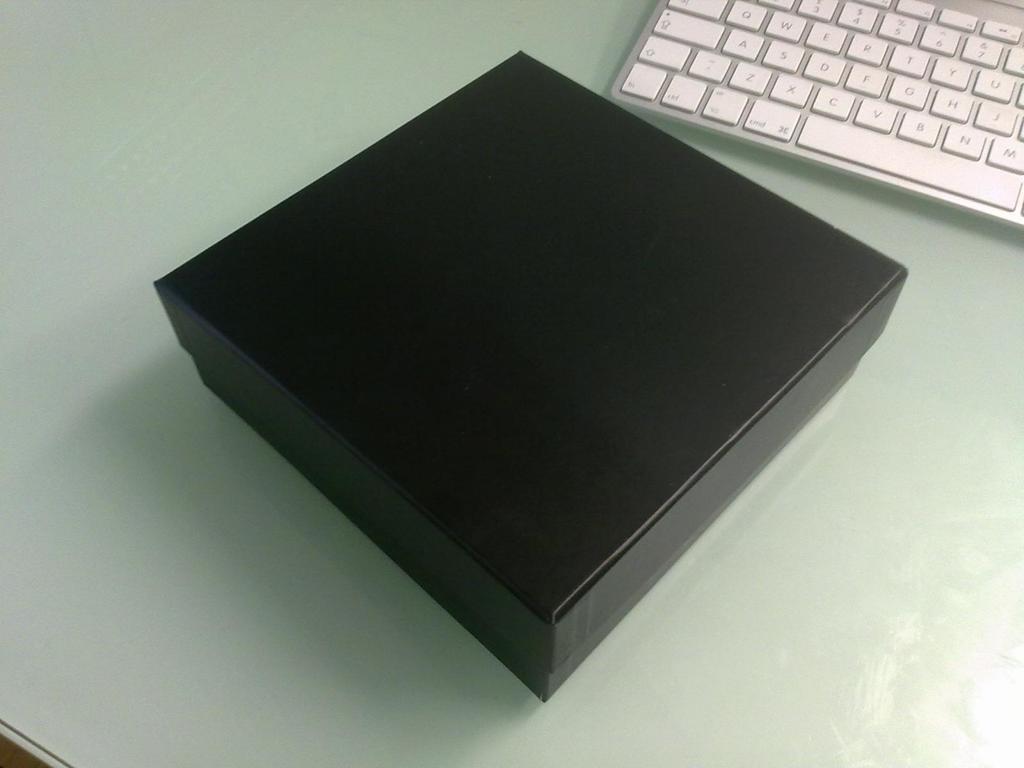Provide a one-sentence caption for the provided image. A square brown box sits next to a silver keyboard, near the cmd key and spacebar. 